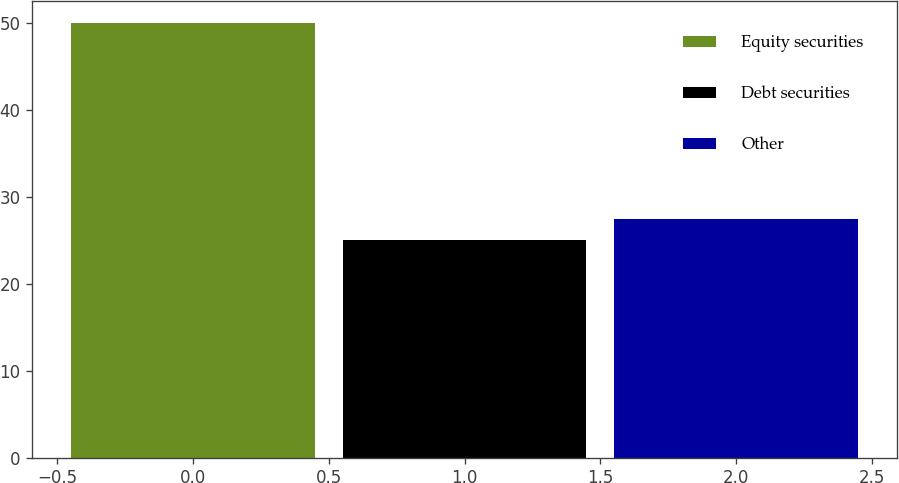Convert chart. <chart><loc_0><loc_0><loc_500><loc_500><bar_chart><fcel>Equity securities<fcel>Debt securities<fcel>Other<nl><fcel>50<fcel>25<fcel>27.5<nl></chart> 